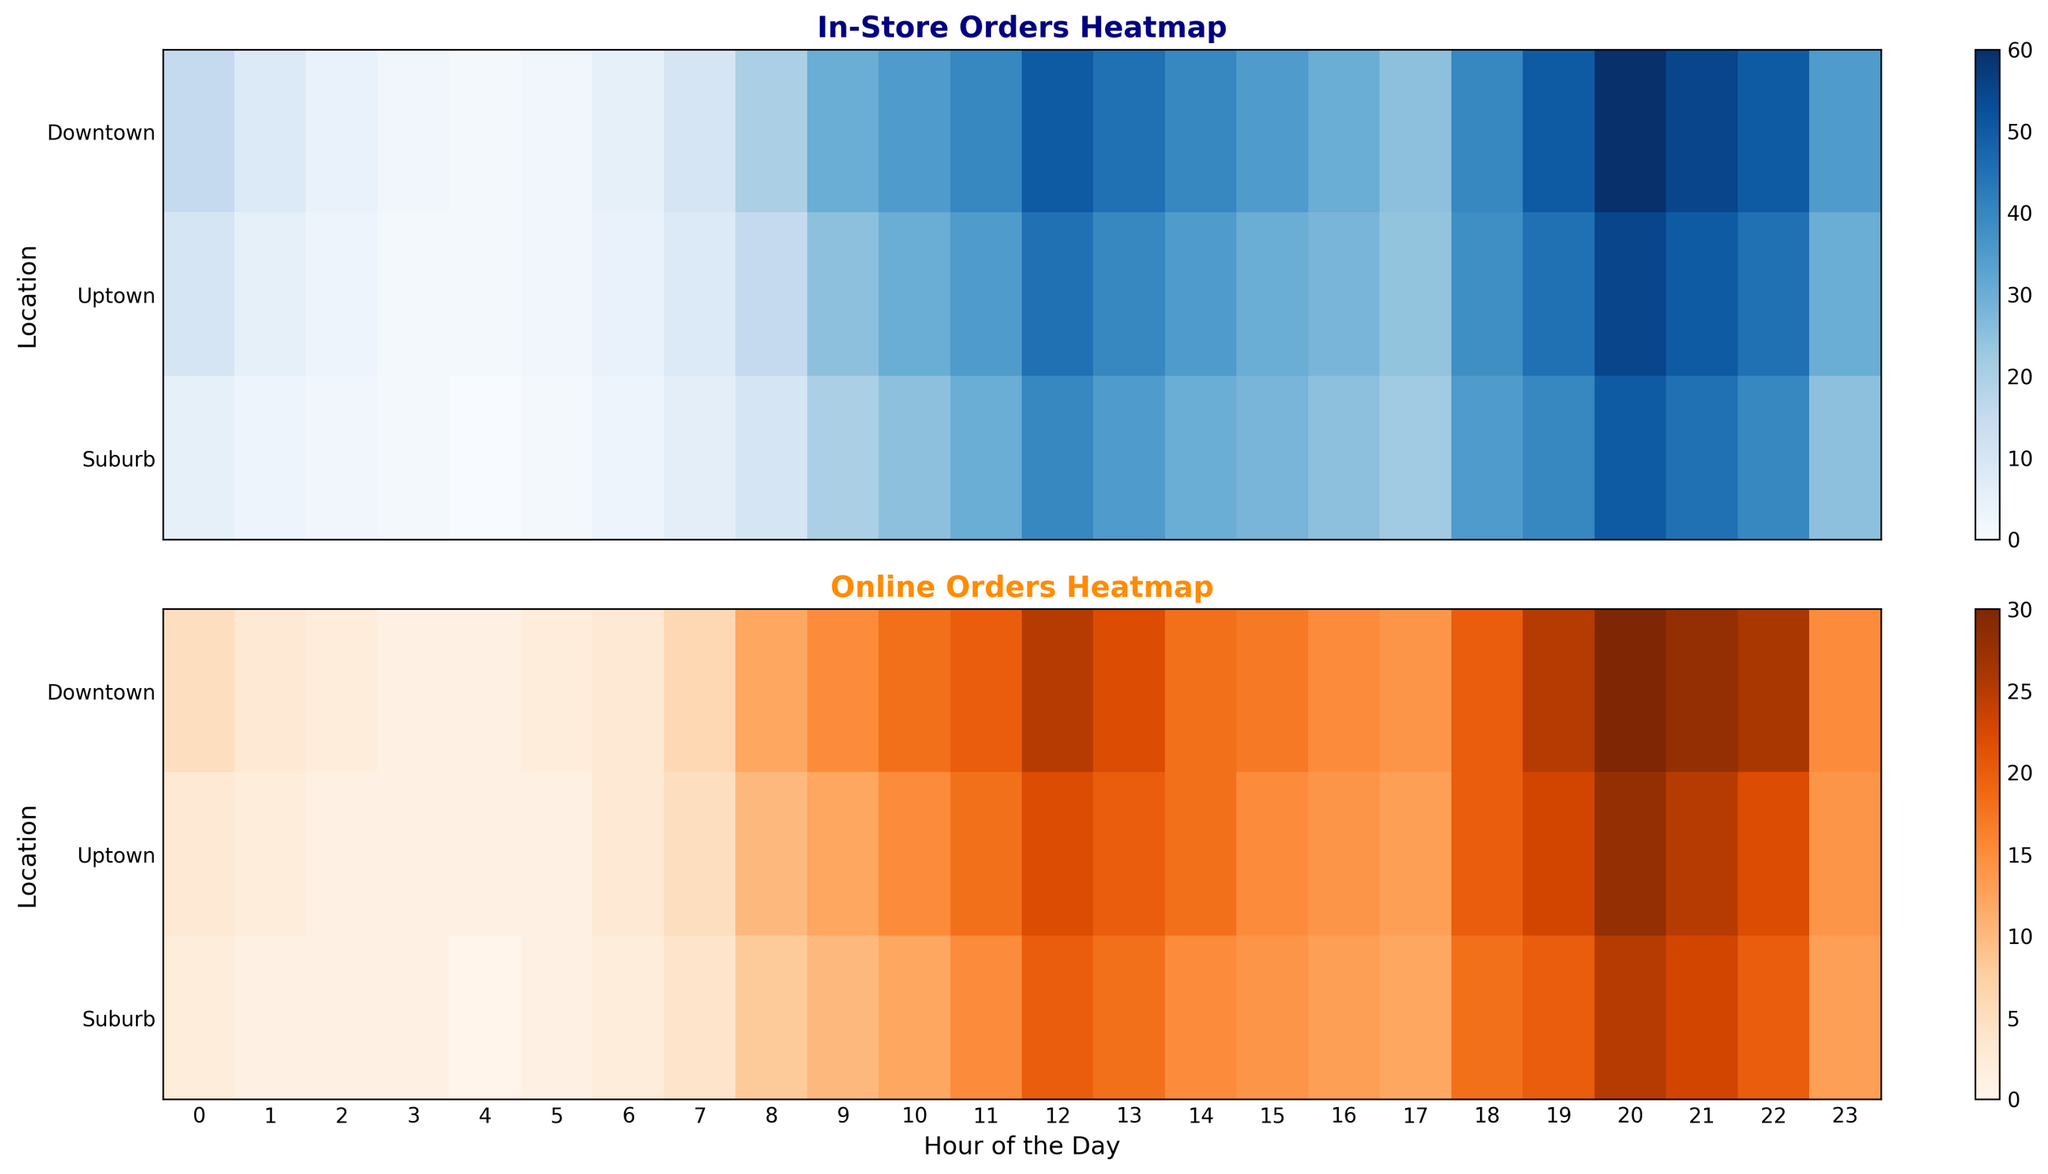What's the peak hour for in-store orders at the Uptown location? First, look at the "In-Store Orders Heatmap" and focus on the row labeled "Uptown." Locate the hour with the darkest blue, indicating the highest number of in-store orders, which is 12.
Answer: 12 PM What's the lowest recorded number of online orders across all locations? Refer to the "Online Orders Heatmap" and find the lightest orange spots. The lightest color corresponds to the smallest number of orders, which is 0, seen at the 4 AM hour for the Suburb location.
Answer: 0 During which hour does the Downtown location have the maximum online orders? Look at the "Online Orders Heatmap" and focus on the row labeled "Downtown." Identify the hour with the darkest orange, which is 20.
Answer: 20 How do in-store versus online orders compare at the 12th hour for the Suburb location? Compare the "In-Store Orders Heatmap" and "Online Orders Heatmap" for the 12th hour (12 PM) for the Suburb row. The in-store orders are darker blue (40) than the online orders which are darker orange but at a slightly lesser intensity (20).
Answer: In-store orders are higher What is the difference between in-store orders and online orders at the 21st hour in the Uptown location? Locate the 21st hour (9 PM) row for Uptown in both heatmaps. The in-store orders are 50 (darker blue) and the online orders are 25 (darker orange). The difference is 50 - 25 = 25.
Answer: 25 Between which two consecutive hours does Downtown experience the largest increase in in-store orders? For Downtown in the "In-Store Orders Heatmap," identify the hours with a noticeable shift from lighter to darker blue. The largest increase occurs from the 8th hour (20 orders) to the 9th hour (30 orders), an increase of 10 orders.
Answer: Between 8 and 9 Which location shows the greatest change in online orders between 3 PM and 8 PM? Evaluate the "Online Orders Heatmap" for all locations between 15:00 and 20:00. The Suburb location shows a significant change (light to darker orange) from 14 to 20 online orders, a change of 6.
Answer: Suburb What's the average number of in-store orders at the Downtown location during the dinner rush hours (5 PM - 8 PM)? Sum the "In-Store Orders Heatmap" values for the Downtown row from 17:00 to 20:00, which are 25, 40, 50, and 60. The sum is 175. Divide by 4 (hours) to get the average: 175 / 4 = 43.75.
Answer: 43.75 